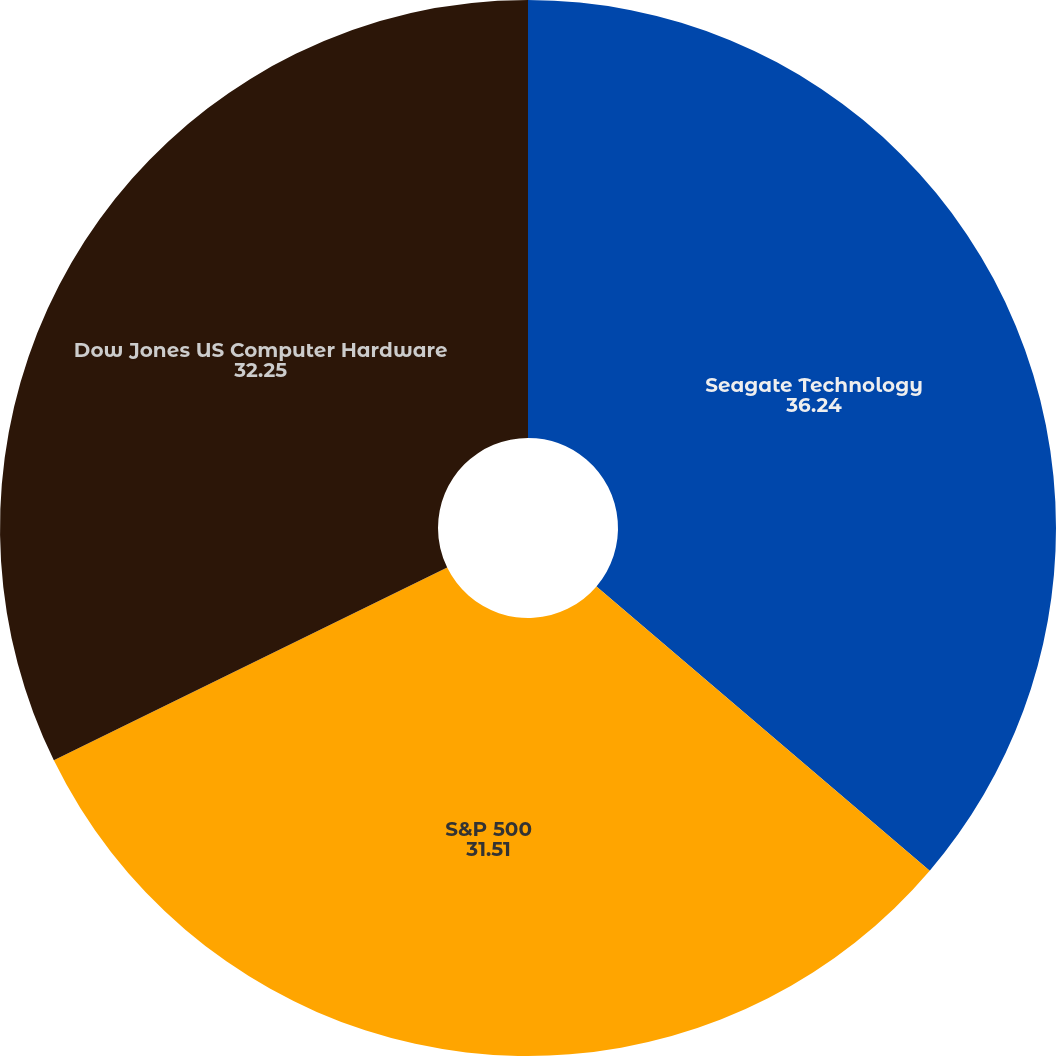Convert chart. <chart><loc_0><loc_0><loc_500><loc_500><pie_chart><fcel>Seagate Technology<fcel>S&P 500<fcel>Dow Jones US Computer Hardware<nl><fcel>36.24%<fcel>31.51%<fcel>32.25%<nl></chart> 